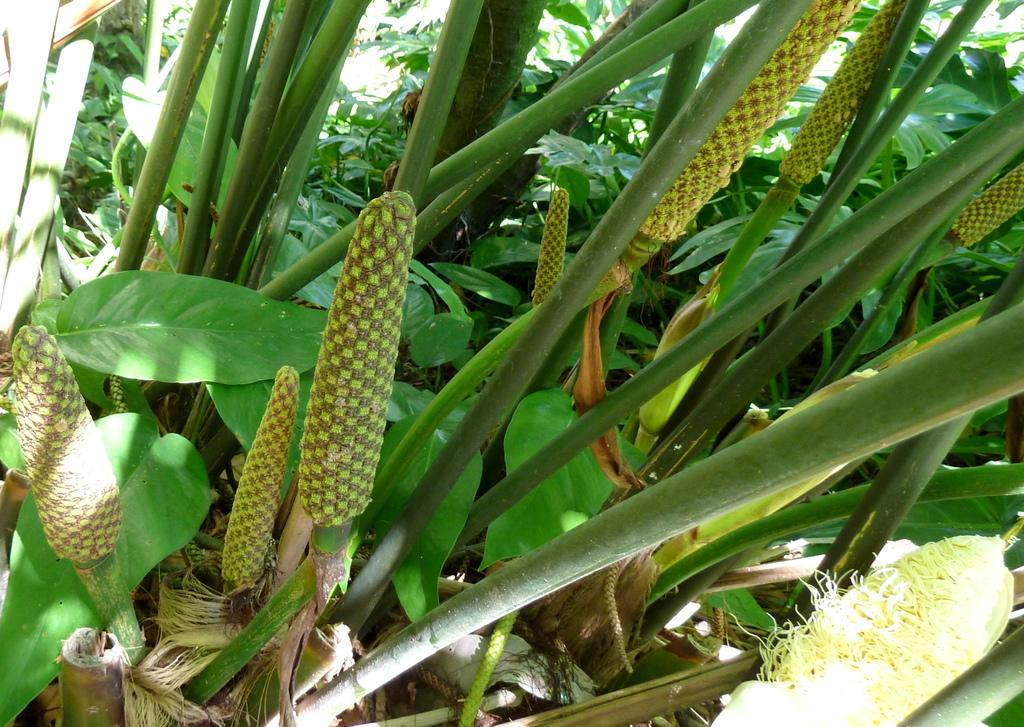What type of plants are in the foreground of the image? There are corn trees in the foreground of the image. What is associated with the corn trees? There are corn cobs associated with the corn trees. What can be seen in the background of the image? The background of the image consists of greenery. What type of toothbrush is visible in the image? There is no toothbrush present in the image. What adjustment needs to be made to the corn trees in the image? There is no need for any adjustment to the corn trees in the image, as they are stationary plants. 